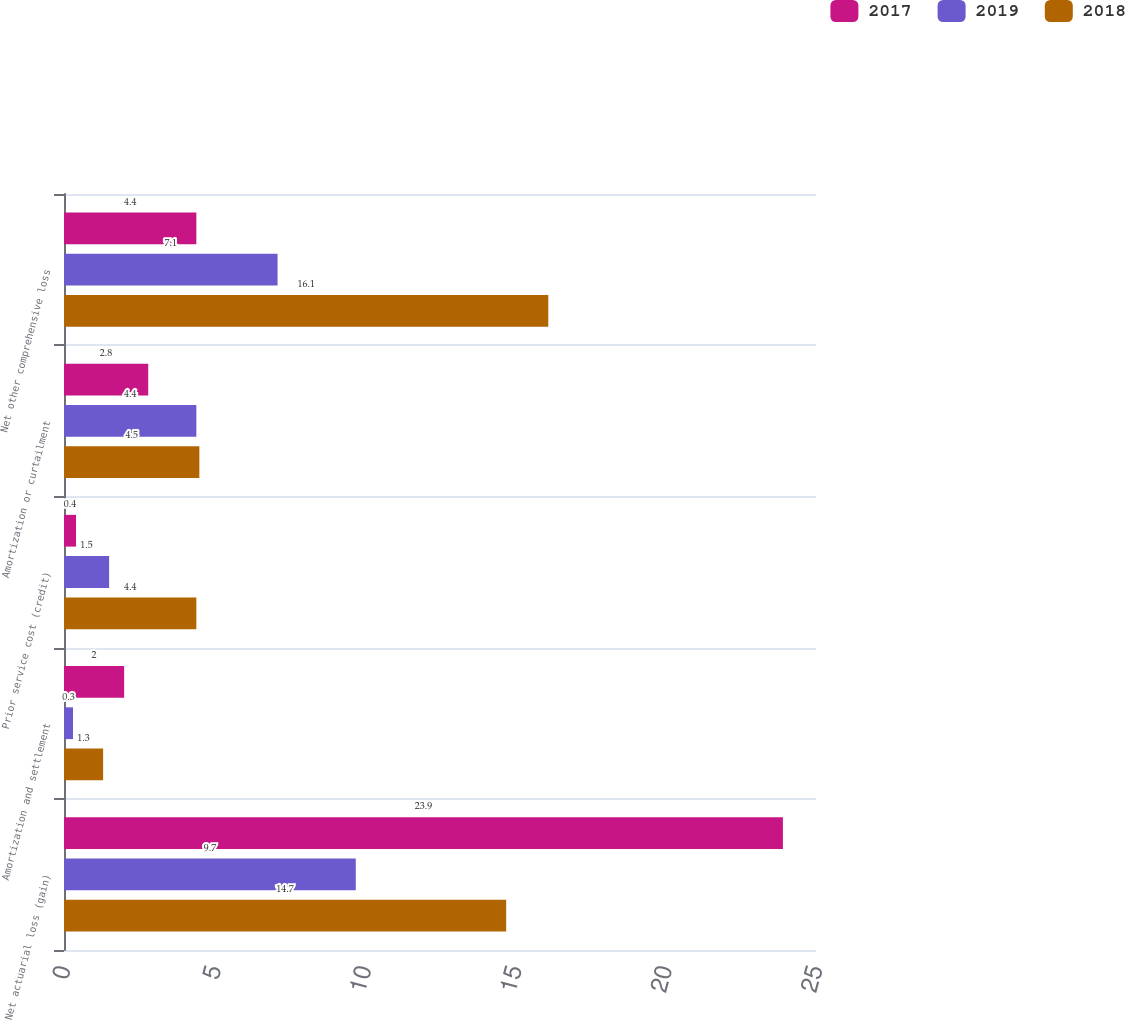<chart> <loc_0><loc_0><loc_500><loc_500><stacked_bar_chart><ecel><fcel>Net actuarial loss (gain)<fcel>Amortization and settlement<fcel>Prior service cost (credit)<fcel>Amortization or curtailment<fcel>Net other comprehensive loss<nl><fcel>2017<fcel>23.9<fcel>2<fcel>0.4<fcel>2.8<fcel>4.4<nl><fcel>2019<fcel>9.7<fcel>0.3<fcel>1.5<fcel>4.4<fcel>7.1<nl><fcel>2018<fcel>14.7<fcel>1.3<fcel>4.4<fcel>4.5<fcel>16.1<nl></chart> 